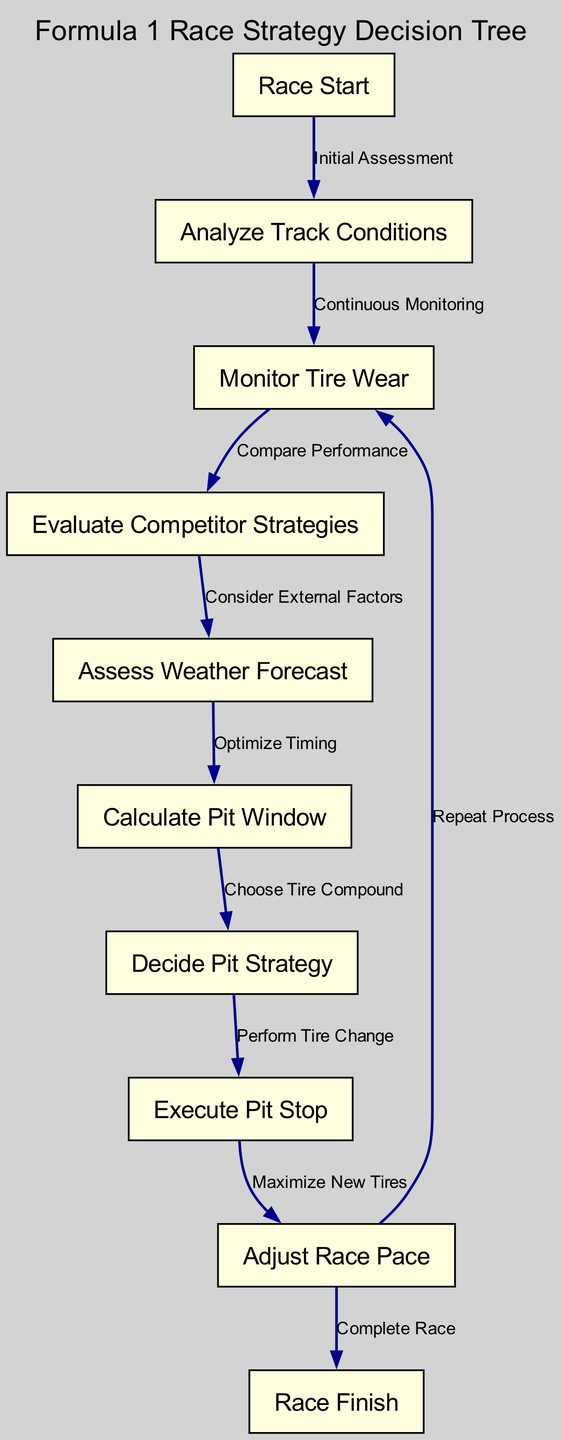What is the starting node in the diagram? The starting node is labeled "Race Start", which is the first point in the decision-making process depicted in the directed graph.
Answer: Race Start How many nodes are represented in the diagram? By counting each unique label in the "nodes" list, we find that there are 10 nodes total in the graph.
Answer: 10 What is the last node in the sequence? The last node is "Race Finish", marking the end of the process as indicated in the diagram flow structure.
Answer: Race Finish Which node follows "Calculate Pit Window"? The node that follows "Calculate Pit Window" is "Decide Pit Strategy", indicating the next step after calculating the timing for a pit stop.
Answer: Decide Pit Strategy What label connects "Analyze Track Conditions" to "Monitor Tire Wear"? The edge connecting "Analyze Track Conditions" to "Monitor Tire Wear" is labeled "Continuous Monitoring", describing the process that occurs between these two nodes.
Answer: Continuous Monitoring Which nodes evaluate external factors in the diagram? The node "Evaluate Competitor Strategies" is directly linked to "Assess Weather Forecast", both playing roles in the assessment of external factors affecting race strategy.
Answer: Evaluate Competitor Strategies, Assess Weather Forecast If tire wear increases significantly, which node does the process return to after "Adjust Race Pace"? If tire wear is significant, the process returns to the "Monitor Tire Wear" node, indicating a need to continuously keep track of tire condition.
Answer: Monitor Tire Wear What is the main purpose of the "Execute Pit Stop" node? The "Execute Pit Stop" node signifies the action taken to perform tire changes during the race, which is essential for maintaining optimal performance on the track.
Answer: Perform Tire Change How does the "Assess Weather Forecast" influence the decision-making process? "Assess Weather Forecast" feeds into "Calculate Pit Window", influencing when the team should plan a pit stop based on predicted conditions during the race.
Answer: Optimize Timing What kind of relationship does "Decide Pit Strategy" have with "Execute Pit Stop"? The relationship is sequential, as "Decide Pit Strategy" directly leads to "Execute Pit Stop", showing that the strategy must be decided before the physical action can take place.
Answer: Perform Tire Change 